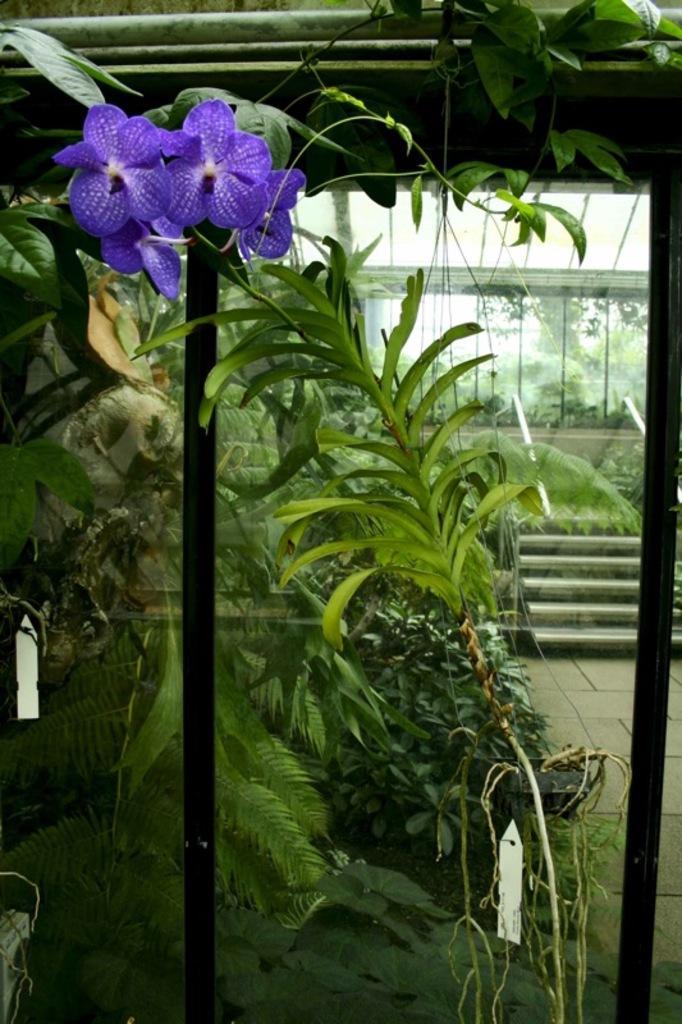Could you give a brief overview of what you see in this image? In this image in front there is a glass window. Behind the window there are plants, flowers, stairs. In the background of the image there is another glass window through which we can see trees and sky. 